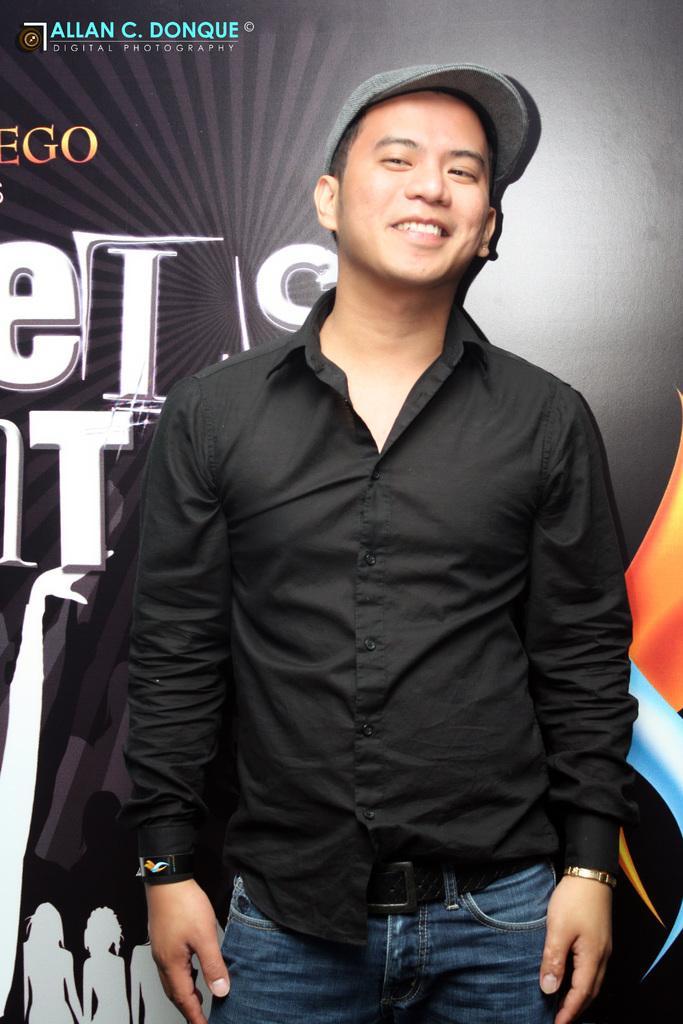How would you summarize this image in a sentence or two? In this image these is a person wearing a black shirt and jeans is wearing a cap. Background of image there is a banner. 